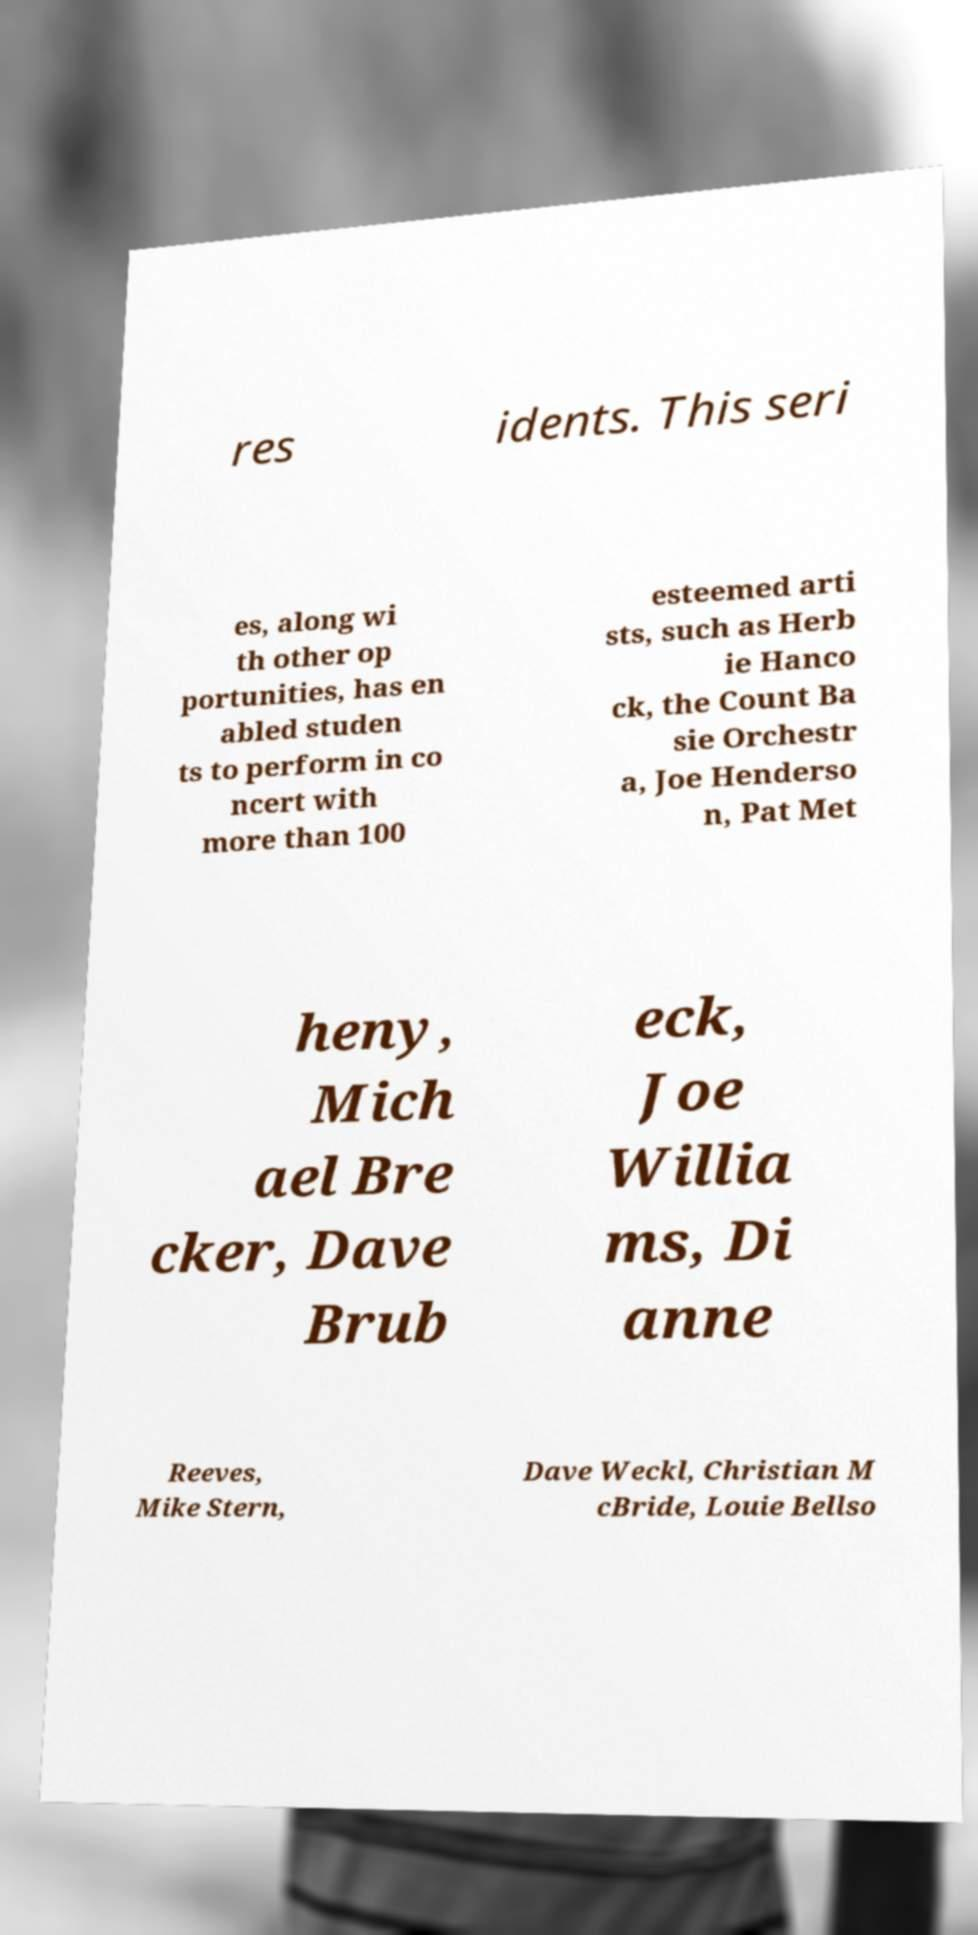There's text embedded in this image that I need extracted. Can you transcribe it verbatim? res idents. This seri es, along wi th other op portunities, has en abled studen ts to perform in co ncert with more than 100 esteemed arti sts, such as Herb ie Hanco ck, the Count Ba sie Orchestr a, Joe Henderso n, Pat Met heny, Mich ael Bre cker, Dave Brub eck, Joe Willia ms, Di anne Reeves, Mike Stern, Dave Weckl, Christian M cBride, Louie Bellso 